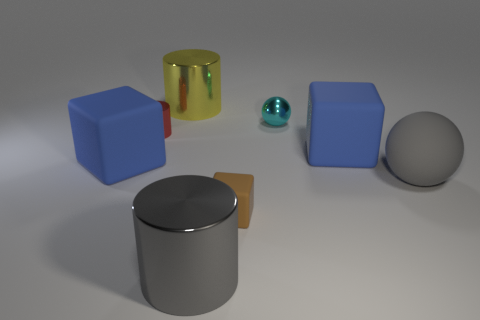Does the gray matte sphere have the same size as the brown thing?
Your answer should be compact. No. What is the shape of the tiny cyan thing that is made of the same material as the tiny red cylinder?
Make the answer very short. Sphere. What number of other things are there of the same shape as the gray metal object?
Offer a very short reply. 2. The matte thing behind the large rubber block in front of the blue matte block on the right side of the gray shiny cylinder is what shape?
Make the answer very short. Cube. How many balls are either cyan objects or big yellow metallic things?
Your answer should be compact. 1. There is a blue cube that is right of the red thing; is there a big gray thing on the left side of it?
Keep it short and to the point. Yes. Is there any other thing that is made of the same material as the large sphere?
Your answer should be very brief. Yes. There is a tiny red object; is its shape the same as the metallic thing in front of the small red metallic cylinder?
Keep it short and to the point. Yes. How many other objects are there of the same size as the red cylinder?
Offer a very short reply. 2. How many brown things are large rubber balls or matte things?
Your answer should be very brief. 1. 